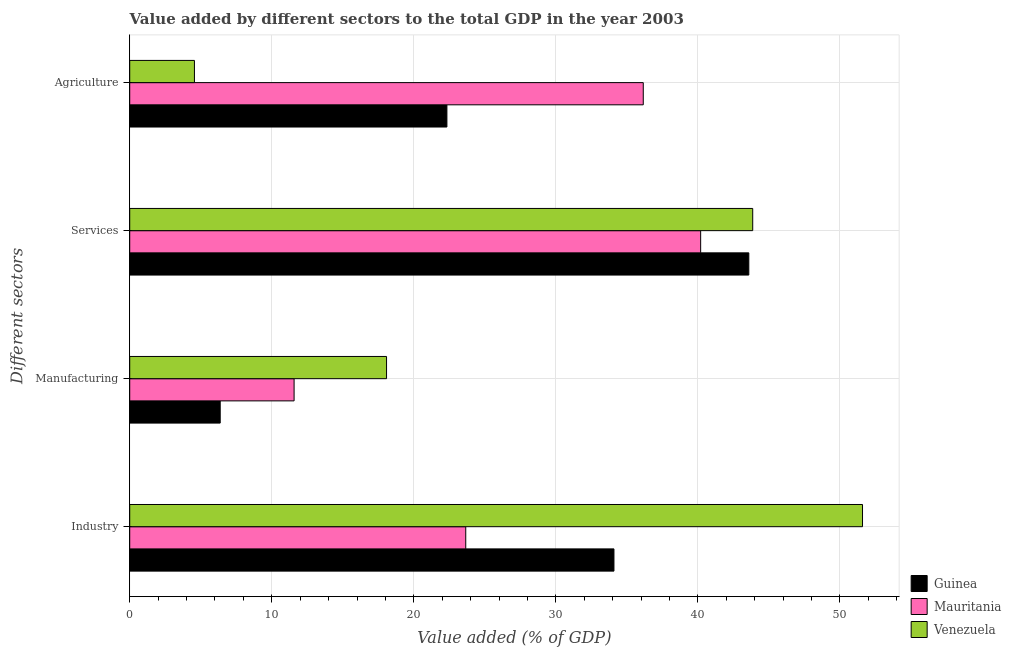How many groups of bars are there?
Provide a succinct answer. 4. Are the number of bars on each tick of the Y-axis equal?
Your answer should be compact. Yes. How many bars are there on the 4th tick from the top?
Offer a terse response. 3. What is the label of the 3rd group of bars from the top?
Give a very brief answer. Manufacturing. What is the value added by manufacturing sector in Mauritania?
Provide a short and direct response. 11.57. Across all countries, what is the maximum value added by manufacturing sector?
Offer a terse response. 18.08. Across all countries, what is the minimum value added by manufacturing sector?
Offer a very short reply. 6.37. In which country was the value added by agricultural sector maximum?
Make the answer very short. Mauritania. In which country was the value added by agricultural sector minimum?
Offer a terse response. Venezuela. What is the total value added by manufacturing sector in the graph?
Provide a short and direct response. 36.02. What is the difference between the value added by services sector in Mauritania and that in Venezuela?
Your answer should be compact. -3.67. What is the difference between the value added by industrial sector in Mauritania and the value added by manufacturing sector in Venezuela?
Your answer should be compact. 5.58. What is the average value added by industrial sector per country?
Your answer should be very brief. 36.44. What is the difference between the value added by manufacturing sector and value added by industrial sector in Guinea?
Your answer should be very brief. -27.72. What is the ratio of the value added by industrial sector in Mauritania to that in Guinea?
Your answer should be compact. 0.69. Is the value added by industrial sector in Venezuela less than that in Guinea?
Keep it short and to the point. No. Is the difference between the value added by services sector in Mauritania and Guinea greater than the difference between the value added by industrial sector in Mauritania and Guinea?
Keep it short and to the point. Yes. What is the difference between the highest and the second highest value added by agricultural sector?
Offer a very short reply. 13.82. What is the difference between the highest and the lowest value added by manufacturing sector?
Provide a succinct answer. 11.71. In how many countries, is the value added by services sector greater than the average value added by services sector taken over all countries?
Offer a terse response. 2. Is it the case that in every country, the sum of the value added by services sector and value added by agricultural sector is greater than the sum of value added by manufacturing sector and value added by industrial sector?
Ensure brevity in your answer.  No. What does the 1st bar from the top in Industry represents?
Offer a very short reply. Venezuela. What does the 2nd bar from the bottom in Services represents?
Ensure brevity in your answer.  Mauritania. Are all the bars in the graph horizontal?
Your answer should be compact. Yes. Are the values on the major ticks of X-axis written in scientific E-notation?
Provide a succinct answer. No. Does the graph contain grids?
Make the answer very short. Yes. What is the title of the graph?
Keep it short and to the point. Value added by different sectors to the total GDP in the year 2003. Does "Philippines" appear as one of the legend labels in the graph?
Provide a succinct answer. No. What is the label or title of the X-axis?
Provide a short and direct response. Value added (% of GDP). What is the label or title of the Y-axis?
Make the answer very short. Different sectors. What is the Value added (% of GDP) in Guinea in Industry?
Offer a very short reply. 34.09. What is the Value added (% of GDP) of Mauritania in Industry?
Give a very brief answer. 23.66. What is the Value added (% of GDP) of Venezuela in Industry?
Your response must be concise. 51.59. What is the Value added (% of GDP) of Guinea in Manufacturing?
Offer a terse response. 6.37. What is the Value added (% of GDP) in Mauritania in Manufacturing?
Your answer should be very brief. 11.57. What is the Value added (% of GDP) in Venezuela in Manufacturing?
Give a very brief answer. 18.08. What is the Value added (% of GDP) in Guinea in Services?
Offer a very short reply. 43.58. What is the Value added (% of GDP) of Mauritania in Services?
Offer a very short reply. 40.19. What is the Value added (% of GDP) in Venezuela in Services?
Your answer should be compact. 43.86. What is the Value added (% of GDP) of Guinea in Agriculture?
Ensure brevity in your answer.  22.33. What is the Value added (% of GDP) in Mauritania in Agriculture?
Your response must be concise. 36.15. What is the Value added (% of GDP) of Venezuela in Agriculture?
Provide a short and direct response. 4.56. Across all Different sectors, what is the maximum Value added (% of GDP) in Guinea?
Your response must be concise. 43.58. Across all Different sectors, what is the maximum Value added (% of GDP) in Mauritania?
Offer a terse response. 40.19. Across all Different sectors, what is the maximum Value added (% of GDP) of Venezuela?
Your answer should be compact. 51.59. Across all Different sectors, what is the minimum Value added (% of GDP) in Guinea?
Provide a short and direct response. 6.37. Across all Different sectors, what is the minimum Value added (% of GDP) of Mauritania?
Provide a succinct answer. 11.57. Across all Different sectors, what is the minimum Value added (% of GDP) in Venezuela?
Offer a terse response. 4.56. What is the total Value added (% of GDP) of Guinea in the graph?
Offer a terse response. 106.37. What is the total Value added (% of GDP) in Mauritania in the graph?
Offer a terse response. 111.57. What is the total Value added (% of GDP) of Venezuela in the graph?
Your answer should be compact. 118.08. What is the difference between the Value added (% of GDP) of Guinea in Industry and that in Manufacturing?
Provide a short and direct response. 27.72. What is the difference between the Value added (% of GDP) in Mauritania in Industry and that in Manufacturing?
Keep it short and to the point. 12.08. What is the difference between the Value added (% of GDP) of Venezuela in Industry and that in Manufacturing?
Make the answer very short. 33.51. What is the difference between the Value added (% of GDP) of Guinea in Industry and that in Services?
Provide a succinct answer. -9.49. What is the difference between the Value added (% of GDP) of Mauritania in Industry and that in Services?
Keep it short and to the point. -16.54. What is the difference between the Value added (% of GDP) of Venezuela in Industry and that in Services?
Give a very brief answer. 7.73. What is the difference between the Value added (% of GDP) in Guinea in Industry and that in Agriculture?
Your answer should be very brief. 11.76. What is the difference between the Value added (% of GDP) in Mauritania in Industry and that in Agriculture?
Make the answer very short. -12.5. What is the difference between the Value added (% of GDP) in Venezuela in Industry and that in Agriculture?
Your answer should be compact. 47.03. What is the difference between the Value added (% of GDP) in Guinea in Manufacturing and that in Services?
Keep it short and to the point. -37.21. What is the difference between the Value added (% of GDP) in Mauritania in Manufacturing and that in Services?
Your answer should be compact. -28.62. What is the difference between the Value added (% of GDP) in Venezuela in Manufacturing and that in Services?
Your answer should be compact. -25.78. What is the difference between the Value added (% of GDP) in Guinea in Manufacturing and that in Agriculture?
Make the answer very short. -15.96. What is the difference between the Value added (% of GDP) of Mauritania in Manufacturing and that in Agriculture?
Ensure brevity in your answer.  -24.58. What is the difference between the Value added (% of GDP) in Venezuela in Manufacturing and that in Agriculture?
Your response must be concise. 13.52. What is the difference between the Value added (% of GDP) of Guinea in Services and that in Agriculture?
Make the answer very short. 21.25. What is the difference between the Value added (% of GDP) in Mauritania in Services and that in Agriculture?
Provide a short and direct response. 4.04. What is the difference between the Value added (% of GDP) of Venezuela in Services and that in Agriculture?
Provide a short and direct response. 39.3. What is the difference between the Value added (% of GDP) of Guinea in Industry and the Value added (% of GDP) of Mauritania in Manufacturing?
Ensure brevity in your answer.  22.52. What is the difference between the Value added (% of GDP) of Guinea in Industry and the Value added (% of GDP) of Venezuela in Manufacturing?
Your answer should be very brief. 16.01. What is the difference between the Value added (% of GDP) in Mauritania in Industry and the Value added (% of GDP) in Venezuela in Manufacturing?
Your answer should be very brief. 5.58. What is the difference between the Value added (% of GDP) in Guinea in Industry and the Value added (% of GDP) in Mauritania in Services?
Your answer should be compact. -6.1. What is the difference between the Value added (% of GDP) of Guinea in Industry and the Value added (% of GDP) of Venezuela in Services?
Provide a short and direct response. -9.77. What is the difference between the Value added (% of GDP) of Mauritania in Industry and the Value added (% of GDP) of Venezuela in Services?
Your answer should be very brief. -20.2. What is the difference between the Value added (% of GDP) in Guinea in Industry and the Value added (% of GDP) in Mauritania in Agriculture?
Your answer should be very brief. -2.06. What is the difference between the Value added (% of GDP) of Guinea in Industry and the Value added (% of GDP) of Venezuela in Agriculture?
Offer a very short reply. 29.53. What is the difference between the Value added (% of GDP) of Mauritania in Industry and the Value added (% of GDP) of Venezuela in Agriculture?
Give a very brief answer. 19.1. What is the difference between the Value added (% of GDP) of Guinea in Manufacturing and the Value added (% of GDP) of Mauritania in Services?
Offer a terse response. -33.82. What is the difference between the Value added (% of GDP) in Guinea in Manufacturing and the Value added (% of GDP) in Venezuela in Services?
Your response must be concise. -37.49. What is the difference between the Value added (% of GDP) in Mauritania in Manufacturing and the Value added (% of GDP) in Venezuela in Services?
Ensure brevity in your answer.  -32.29. What is the difference between the Value added (% of GDP) of Guinea in Manufacturing and the Value added (% of GDP) of Mauritania in Agriculture?
Your response must be concise. -29.78. What is the difference between the Value added (% of GDP) of Guinea in Manufacturing and the Value added (% of GDP) of Venezuela in Agriculture?
Offer a terse response. 1.81. What is the difference between the Value added (% of GDP) of Mauritania in Manufacturing and the Value added (% of GDP) of Venezuela in Agriculture?
Make the answer very short. 7.02. What is the difference between the Value added (% of GDP) of Guinea in Services and the Value added (% of GDP) of Mauritania in Agriculture?
Offer a very short reply. 7.43. What is the difference between the Value added (% of GDP) in Guinea in Services and the Value added (% of GDP) in Venezuela in Agriculture?
Provide a short and direct response. 39.03. What is the difference between the Value added (% of GDP) in Mauritania in Services and the Value added (% of GDP) in Venezuela in Agriculture?
Offer a terse response. 35.64. What is the average Value added (% of GDP) of Guinea per Different sectors?
Your answer should be compact. 26.59. What is the average Value added (% of GDP) in Mauritania per Different sectors?
Ensure brevity in your answer.  27.89. What is the average Value added (% of GDP) in Venezuela per Different sectors?
Provide a short and direct response. 29.52. What is the difference between the Value added (% of GDP) in Guinea and Value added (% of GDP) in Mauritania in Industry?
Your answer should be very brief. 10.43. What is the difference between the Value added (% of GDP) in Guinea and Value added (% of GDP) in Venezuela in Industry?
Ensure brevity in your answer.  -17.5. What is the difference between the Value added (% of GDP) of Mauritania and Value added (% of GDP) of Venezuela in Industry?
Make the answer very short. -27.93. What is the difference between the Value added (% of GDP) of Guinea and Value added (% of GDP) of Mauritania in Manufacturing?
Provide a short and direct response. -5.2. What is the difference between the Value added (% of GDP) of Guinea and Value added (% of GDP) of Venezuela in Manufacturing?
Your response must be concise. -11.71. What is the difference between the Value added (% of GDP) in Mauritania and Value added (% of GDP) in Venezuela in Manufacturing?
Give a very brief answer. -6.51. What is the difference between the Value added (% of GDP) in Guinea and Value added (% of GDP) in Mauritania in Services?
Ensure brevity in your answer.  3.39. What is the difference between the Value added (% of GDP) of Guinea and Value added (% of GDP) of Venezuela in Services?
Your answer should be very brief. -0.28. What is the difference between the Value added (% of GDP) in Mauritania and Value added (% of GDP) in Venezuela in Services?
Your answer should be compact. -3.67. What is the difference between the Value added (% of GDP) in Guinea and Value added (% of GDP) in Mauritania in Agriculture?
Offer a terse response. -13.82. What is the difference between the Value added (% of GDP) in Guinea and Value added (% of GDP) in Venezuela in Agriculture?
Provide a short and direct response. 17.77. What is the difference between the Value added (% of GDP) in Mauritania and Value added (% of GDP) in Venezuela in Agriculture?
Keep it short and to the point. 31.6. What is the ratio of the Value added (% of GDP) in Guinea in Industry to that in Manufacturing?
Offer a terse response. 5.35. What is the ratio of the Value added (% of GDP) of Mauritania in Industry to that in Manufacturing?
Your response must be concise. 2.04. What is the ratio of the Value added (% of GDP) of Venezuela in Industry to that in Manufacturing?
Provide a short and direct response. 2.85. What is the ratio of the Value added (% of GDP) of Guinea in Industry to that in Services?
Keep it short and to the point. 0.78. What is the ratio of the Value added (% of GDP) in Mauritania in Industry to that in Services?
Your answer should be very brief. 0.59. What is the ratio of the Value added (% of GDP) of Venezuela in Industry to that in Services?
Your answer should be very brief. 1.18. What is the ratio of the Value added (% of GDP) of Guinea in Industry to that in Agriculture?
Make the answer very short. 1.53. What is the ratio of the Value added (% of GDP) of Mauritania in Industry to that in Agriculture?
Give a very brief answer. 0.65. What is the ratio of the Value added (% of GDP) of Venezuela in Industry to that in Agriculture?
Provide a short and direct response. 11.32. What is the ratio of the Value added (% of GDP) in Guinea in Manufacturing to that in Services?
Your response must be concise. 0.15. What is the ratio of the Value added (% of GDP) of Mauritania in Manufacturing to that in Services?
Offer a terse response. 0.29. What is the ratio of the Value added (% of GDP) in Venezuela in Manufacturing to that in Services?
Make the answer very short. 0.41. What is the ratio of the Value added (% of GDP) in Guinea in Manufacturing to that in Agriculture?
Your response must be concise. 0.29. What is the ratio of the Value added (% of GDP) of Mauritania in Manufacturing to that in Agriculture?
Keep it short and to the point. 0.32. What is the ratio of the Value added (% of GDP) of Venezuela in Manufacturing to that in Agriculture?
Keep it short and to the point. 3.97. What is the ratio of the Value added (% of GDP) in Guinea in Services to that in Agriculture?
Ensure brevity in your answer.  1.95. What is the ratio of the Value added (% of GDP) of Mauritania in Services to that in Agriculture?
Give a very brief answer. 1.11. What is the ratio of the Value added (% of GDP) of Venezuela in Services to that in Agriculture?
Provide a short and direct response. 9.63. What is the difference between the highest and the second highest Value added (% of GDP) of Guinea?
Your response must be concise. 9.49. What is the difference between the highest and the second highest Value added (% of GDP) of Mauritania?
Give a very brief answer. 4.04. What is the difference between the highest and the second highest Value added (% of GDP) of Venezuela?
Ensure brevity in your answer.  7.73. What is the difference between the highest and the lowest Value added (% of GDP) in Guinea?
Ensure brevity in your answer.  37.21. What is the difference between the highest and the lowest Value added (% of GDP) in Mauritania?
Your response must be concise. 28.62. What is the difference between the highest and the lowest Value added (% of GDP) in Venezuela?
Keep it short and to the point. 47.03. 